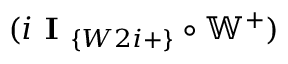Convert formula to latex. <formula><loc_0><loc_0><loc_500><loc_500>( i I _ { \{ W 2 i + \} } \circ \mathbb { W } ^ { + } )</formula> 